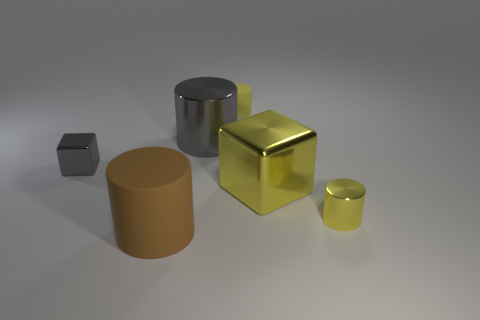Could you infer what the small dark object might be given the context of the other objects? The small dark object appears to be a cube shape with a solid color that contrasts with the shiny metallic textures of the yellow objects. Based on its appearance and assuming the other objects are representative of geometric shapes used in an artistic or educational context, it's possible that the dark cube is just another geometric form intended to complement the collection by providing a visual and textural counterpoint. 